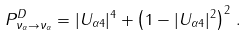<formula> <loc_0><loc_0><loc_500><loc_500>P ^ { D } _ { \nu _ { \alpha } \to \nu _ { \alpha } } = | U _ { \alpha 4 } | ^ { 4 } + \left ( 1 - | U _ { \alpha 4 } | ^ { 2 } \right ) ^ { 2 } \, .</formula> 